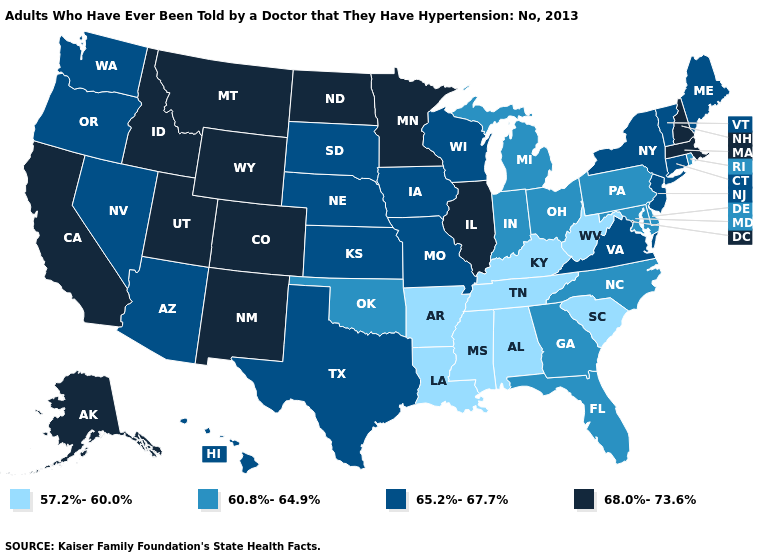Does the map have missing data?
Quick response, please. No. Does Pennsylvania have the same value as Georgia?
Keep it brief. Yes. What is the highest value in the South ?
Keep it brief. 65.2%-67.7%. Name the states that have a value in the range 65.2%-67.7%?
Keep it brief. Arizona, Connecticut, Hawaii, Iowa, Kansas, Maine, Missouri, Nebraska, Nevada, New Jersey, New York, Oregon, South Dakota, Texas, Vermont, Virginia, Washington, Wisconsin. What is the value of New Jersey?
Keep it brief. 65.2%-67.7%. Name the states that have a value in the range 65.2%-67.7%?
Answer briefly. Arizona, Connecticut, Hawaii, Iowa, Kansas, Maine, Missouri, Nebraska, Nevada, New Jersey, New York, Oregon, South Dakota, Texas, Vermont, Virginia, Washington, Wisconsin. What is the value of South Carolina?
Keep it brief. 57.2%-60.0%. What is the lowest value in the Northeast?
Keep it brief. 60.8%-64.9%. What is the highest value in the Northeast ?
Be succinct. 68.0%-73.6%. Which states hav the highest value in the MidWest?
Give a very brief answer. Illinois, Minnesota, North Dakota. What is the value of North Carolina?
Concise answer only. 60.8%-64.9%. Name the states that have a value in the range 60.8%-64.9%?
Keep it brief. Delaware, Florida, Georgia, Indiana, Maryland, Michigan, North Carolina, Ohio, Oklahoma, Pennsylvania, Rhode Island. What is the value of Iowa?
Give a very brief answer. 65.2%-67.7%. Name the states that have a value in the range 57.2%-60.0%?
Concise answer only. Alabama, Arkansas, Kentucky, Louisiana, Mississippi, South Carolina, Tennessee, West Virginia. Name the states that have a value in the range 57.2%-60.0%?
Give a very brief answer. Alabama, Arkansas, Kentucky, Louisiana, Mississippi, South Carolina, Tennessee, West Virginia. 